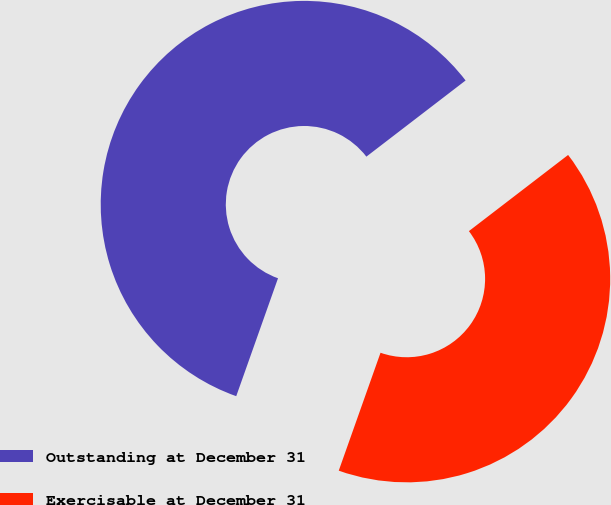Convert chart. <chart><loc_0><loc_0><loc_500><loc_500><pie_chart><fcel>Outstanding at December 31<fcel>Exercisable at December 31<nl><fcel>59.16%<fcel>40.84%<nl></chart> 